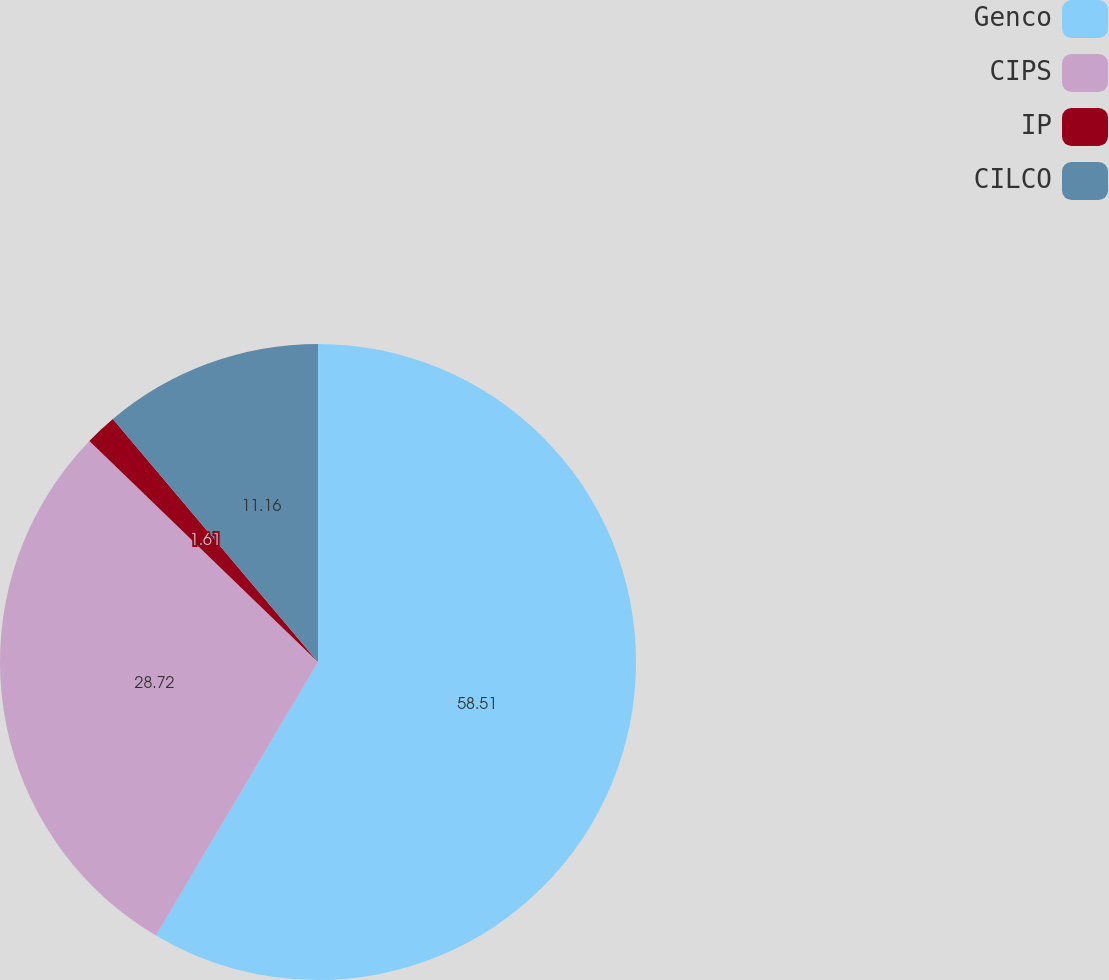Convert chart. <chart><loc_0><loc_0><loc_500><loc_500><pie_chart><fcel>Genco<fcel>CIPS<fcel>IP<fcel>CILCO<nl><fcel>58.52%<fcel>28.72%<fcel>1.61%<fcel>11.16%<nl></chart> 